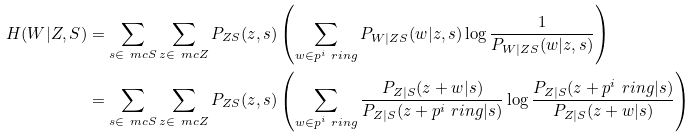Convert formula to latex. <formula><loc_0><loc_0><loc_500><loc_500>H ( W | Z , S ) & = \sum _ { s \in \ m c { S } } \sum _ { z \in \ m c { Z } } P _ { Z S } ( z , s ) \left ( \sum _ { w \in p ^ { i } \ r i n g } P _ { W | Z S } ( w | z , s ) \log \frac { 1 } { P _ { W | Z S } ( w | z , s ) } \right ) \\ & = \sum _ { s \in \ m c { S } } \sum _ { z \in \ m c { Z } } P _ { Z S } ( z , s ) \left ( \sum _ { w \in p ^ { i } \ r i n g } \frac { P _ { Z | S } ( z + w | s ) } { P _ { Z | S } ( z + p ^ { i } \ r i n g | s ) } \log \frac { P _ { Z | S } ( z + p ^ { i } \ r i n g | s ) } { P _ { Z | S } ( z + w | s ) } \right )</formula> 